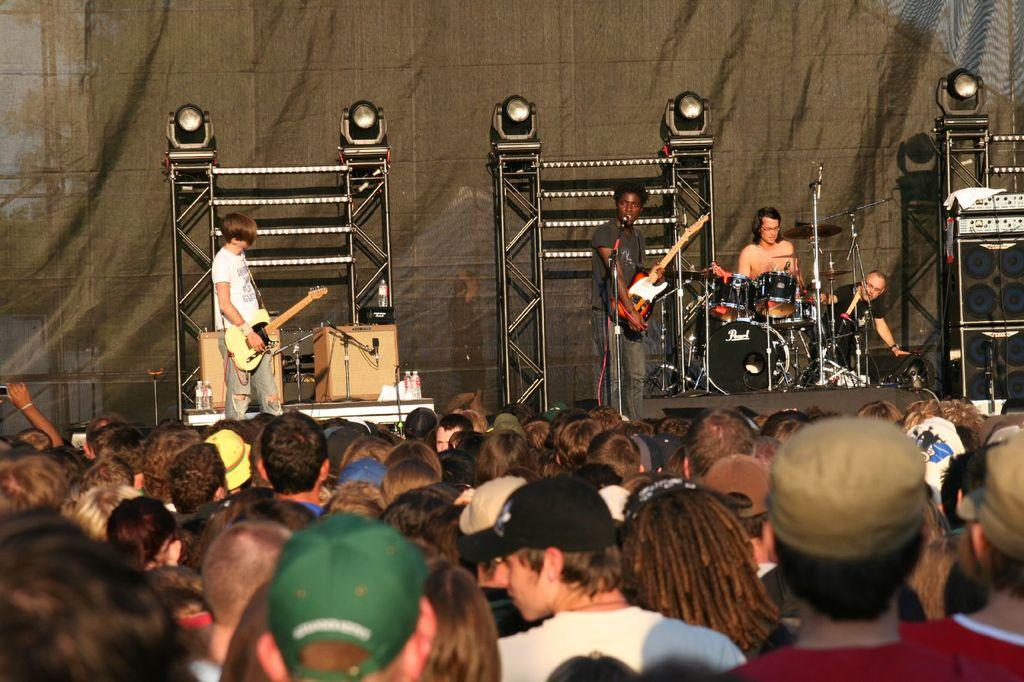What type of event is taking place in the image? The image is of a concert. What can be seen on the floor in the image? There are people standing on the floor. How many people are playing musical instruments on the stage? There are four people playing musical instruments on the stage. What type of story is being told by the can on the stage? There is no can present on the stage in the image, and therefore no story is being told by a can. 